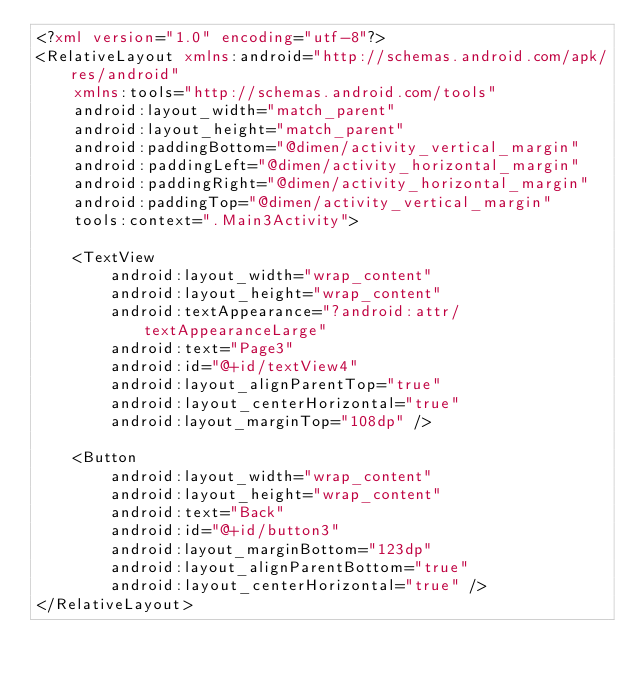Convert code to text. <code><loc_0><loc_0><loc_500><loc_500><_XML_><?xml version="1.0" encoding="utf-8"?>
<RelativeLayout xmlns:android="http://schemas.android.com/apk/res/android"
    xmlns:tools="http://schemas.android.com/tools"
    android:layout_width="match_parent"
    android:layout_height="match_parent"
    android:paddingBottom="@dimen/activity_vertical_margin"
    android:paddingLeft="@dimen/activity_horizontal_margin"
    android:paddingRight="@dimen/activity_horizontal_margin"
    android:paddingTop="@dimen/activity_vertical_margin"
    tools:context=".Main3Activity">

    <TextView
        android:layout_width="wrap_content"
        android:layout_height="wrap_content"
        android:textAppearance="?android:attr/textAppearanceLarge"
        android:text="Page3"
        android:id="@+id/textView4"
        android:layout_alignParentTop="true"
        android:layout_centerHorizontal="true"
        android:layout_marginTop="108dp" />

    <Button
        android:layout_width="wrap_content"
        android:layout_height="wrap_content"
        android:text="Back"
        android:id="@+id/button3"
        android:layout_marginBottom="123dp"
        android:layout_alignParentBottom="true"
        android:layout_centerHorizontal="true" />
</RelativeLayout>
</code> 